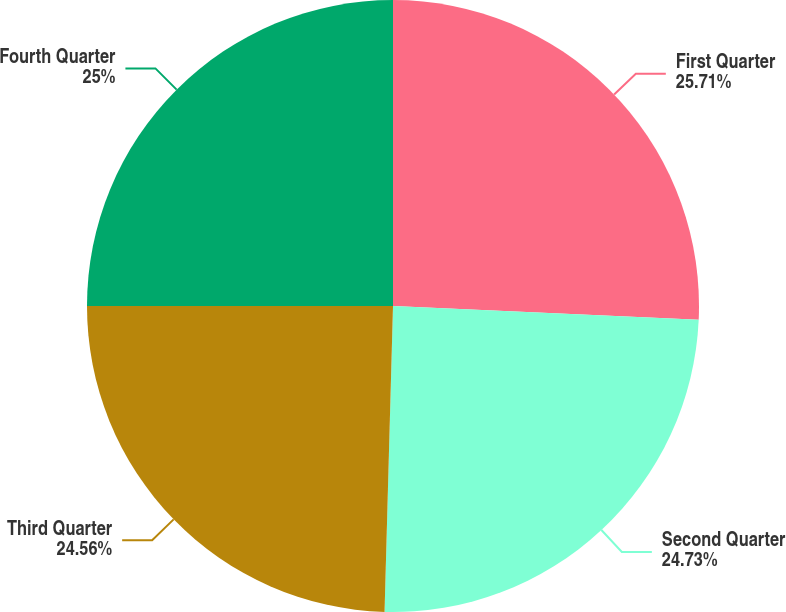Convert chart to OTSL. <chart><loc_0><loc_0><loc_500><loc_500><pie_chart><fcel>First Quarter<fcel>Second Quarter<fcel>Third Quarter<fcel>Fourth Quarter<nl><fcel>25.71%<fcel>24.73%<fcel>24.56%<fcel>25.0%<nl></chart> 